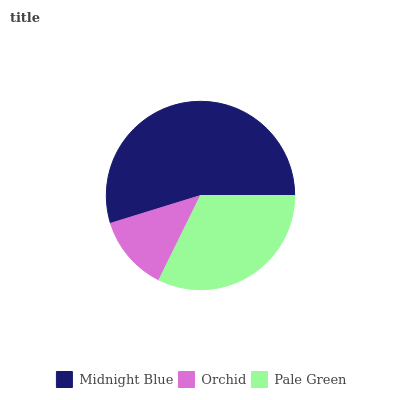Is Orchid the minimum?
Answer yes or no. Yes. Is Midnight Blue the maximum?
Answer yes or no. Yes. Is Pale Green the minimum?
Answer yes or no. No. Is Pale Green the maximum?
Answer yes or no. No. Is Pale Green greater than Orchid?
Answer yes or no. Yes. Is Orchid less than Pale Green?
Answer yes or no. Yes. Is Orchid greater than Pale Green?
Answer yes or no. No. Is Pale Green less than Orchid?
Answer yes or no. No. Is Pale Green the high median?
Answer yes or no. Yes. Is Pale Green the low median?
Answer yes or no. Yes. Is Orchid the high median?
Answer yes or no. No. Is Orchid the low median?
Answer yes or no. No. 